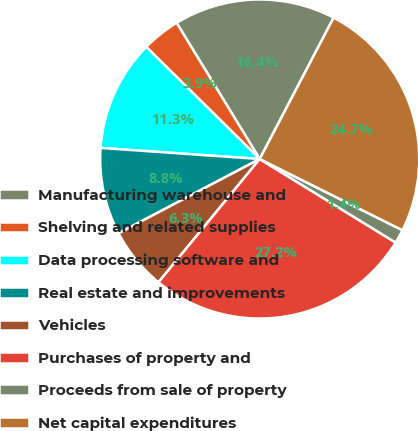Convert chart to OTSL. <chart><loc_0><loc_0><loc_500><loc_500><pie_chart><fcel>Manufacturing warehouse and<fcel>Shelving and related supplies<fcel>Data processing software and<fcel>Real estate and improvements<fcel>Vehicles<fcel>Purchases of property and<fcel>Proceeds from sale of property<fcel>Net capital expenditures<nl><fcel>16.39%<fcel>3.88%<fcel>11.29%<fcel>8.82%<fcel>6.35%<fcel>27.17%<fcel>1.41%<fcel>24.7%<nl></chart> 